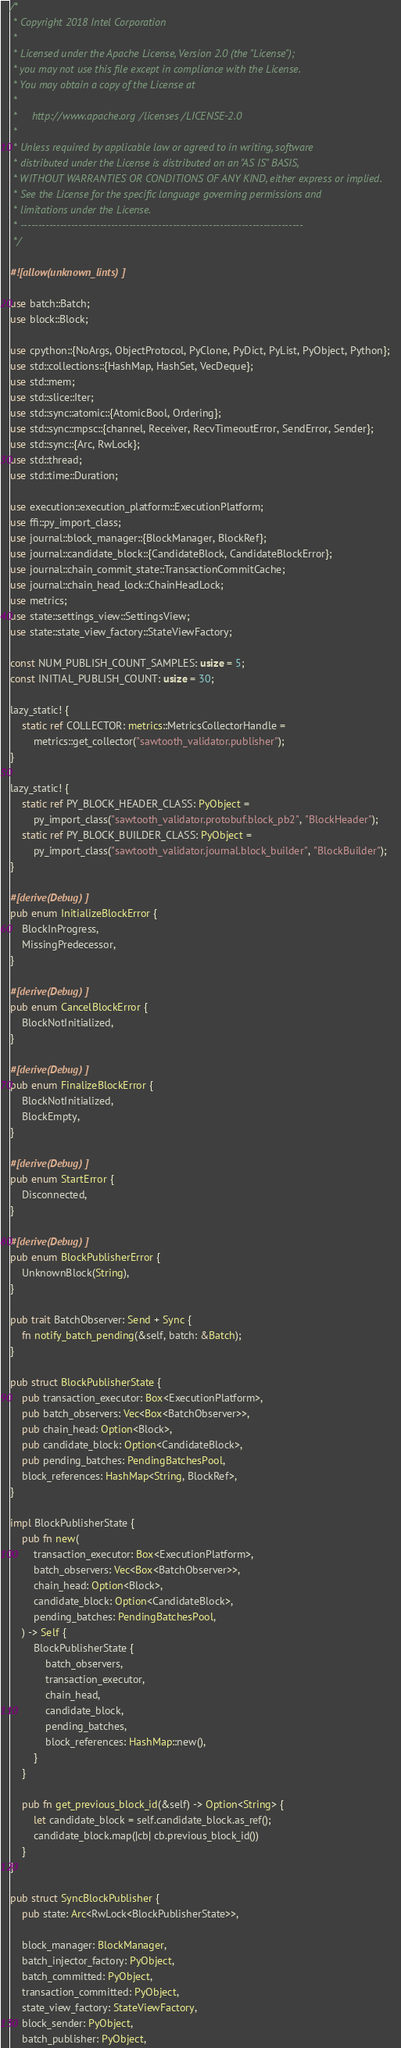<code> <loc_0><loc_0><loc_500><loc_500><_Rust_>/*
 * Copyright 2018 Intel Corporation
 *
 * Licensed under the Apache License, Version 2.0 (the "License");
 * you may not use this file except in compliance with the License.
 * You may obtain a copy of the License at
 *
 *     http://www.apache.org/licenses/LICENSE-2.0
 *
 * Unless required by applicable law or agreed to in writing, software
 * distributed under the License is distributed on an "AS IS" BASIS,
 * WITHOUT WARRANTIES OR CONDITIONS OF ANY KIND, either express or implied.
 * See the License for the specific language governing permissions and
 * limitations under the License.
 * ------------------------------------------------------------------------------
 */

#![allow(unknown_lints)]

use batch::Batch;
use block::Block;

use cpython::{NoArgs, ObjectProtocol, PyClone, PyDict, PyList, PyObject, Python};
use std::collections::{HashMap, HashSet, VecDeque};
use std::mem;
use std::slice::Iter;
use std::sync::atomic::{AtomicBool, Ordering};
use std::sync::mpsc::{channel, Receiver, RecvTimeoutError, SendError, Sender};
use std::sync::{Arc, RwLock};
use std::thread;
use std::time::Duration;

use execution::execution_platform::ExecutionPlatform;
use ffi::py_import_class;
use journal::block_manager::{BlockManager, BlockRef};
use journal::candidate_block::{CandidateBlock, CandidateBlockError};
use journal::chain_commit_state::TransactionCommitCache;
use journal::chain_head_lock::ChainHeadLock;
use metrics;
use state::settings_view::SettingsView;
use state::state_view_factory::StateViewFactory;

const NUM_PUBLISH_COUNT_SAMPLES: usize = 5;
const INITIAL_PUBLISH_COUNT: usize = 30;

lazy_static! {
    static ref COLLECTOR: metrics::MetricsCollectorHandle =
        metrics::get_collector("sawtooth_validator.publisher");
}

lazy_static! {
    static ref PY_BLOCK_HEADER_CLASS: PyObject =
        py_import_class("sawtooth_validator.protobuf.block_pb2", "BlockHeader");
    static ref PY_BLOCK_BUILDER_CLASS: PyObject =
        py_import_class("sawtooth_validator.journal.block_builder", "BlockBuilder");
}

#[derive(Debug)]
pub enum InitializeBlockError {
    BlockInProgress,
    MissingPredecessor,
}

#[derive(Debug)]
pub enum CancelBlockError {
    BlockNotInitialized,
}

#[derive(Debug)]
pub enum FinalizeBlockError {
    BlockNotInitialized,
    BlockEmpty,
}

#[derive(Debug)]
pub enum StartError {
    Disconnected,
}

#[derive(Debug)]
pub enum BlockPublisherError {
    UnknownBlock(String),
}

pub trait BatchObserver: Send + Sync {
    fn notify_batch_pending(&self, batch: &Batch);
}

pub struct BlockPublisherState {
    pub transaction_executor: Box<ExecutionPlatform>,
    pub batch_observers: Vec<Box<BatchObserver>>,
    pub chain_head: Option<Block>,
    pub candidate_block: Option<CandidateBlock>,
    pub pending_batches: PendingBatchesPool,
    block_references: HashMap<String, BlockRef>,
}

impl BlockPublisherState {
    pub fn new(
        transaction_executor: Box<ExecutionPlatform>,
        batch_observers: Vec<Box<BatchObserver>>,
        chain_head: Option<Block>,
        candidate_block: Option<CandidateBlock>,
        pending_batches: PendingBatchesPool,
    ) -> Self {
        BlockPublisherState {
            batch_observers,
            transaction_executor,
            chain_head,
            candidate_block,
            pending_batches,
            block_references: HashMap::new(),
        }
    }

    pub fn get_previous_block_id(&self) -> Option<String> {
        let candidate_block = self.candidate_block.as_ref();
        candidate_block.map(|cb| cb.previous_block_id())
    }
}

pub struct SyncBlockPublisher {
    pub state: Arc<RwLock<BlockPublisherState>>,

    block_manager: BlockManager,
    batch_injector_factory: PyObject,
    batch_committed: PyObject,
    transaction_committed: PyObject,
    state_view_factory: StateViewFactory,
    block_sender: PyObject,
    batch_publisher: PyObject,</code> 